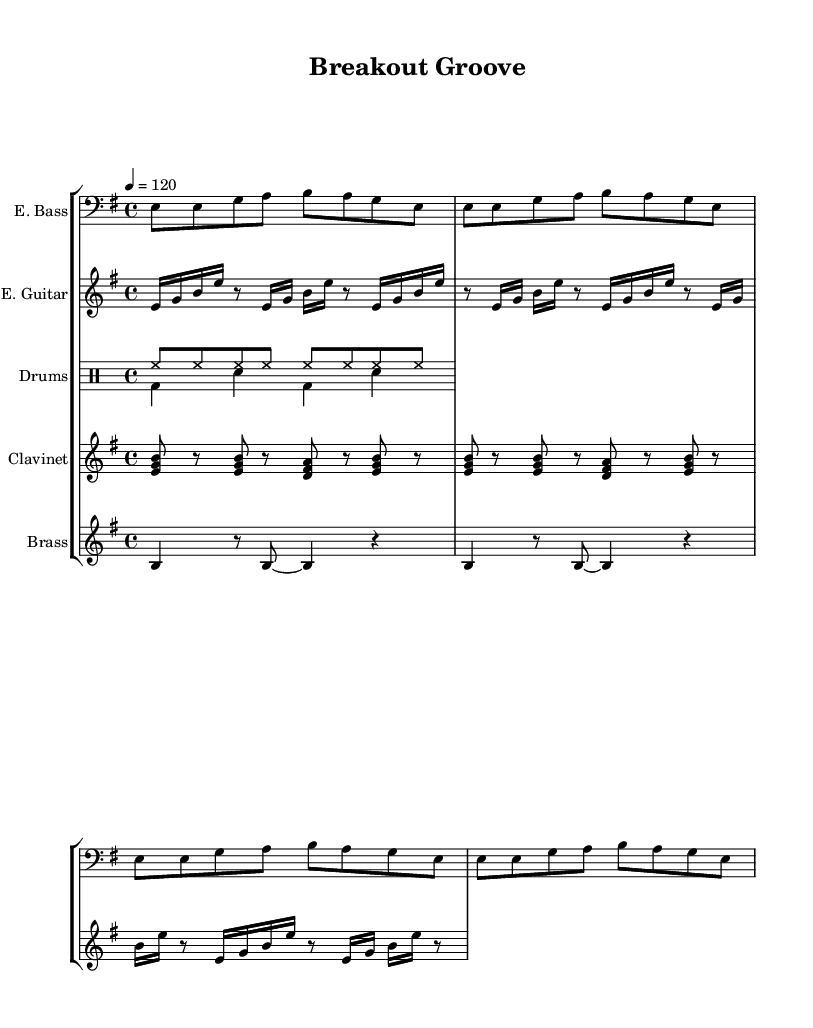What is the key signature of this music? The key signature of the piece is E minor, which has one sharp (F#). This is found at the beginning of the score.
Answer: E minor What is the time signature of this music? The time signature shown in the score is 4/4, which means there are four beats in a measure and the quarter note gets one beat. This is indicated at the start of the music.
Answer: 4/4 What is the tempo marking of this music? The tempo marking indicates a tempo of 120 beats per minute, shown as "4 = 120" in the score. This means the quarter note is played at a tempo of 120.
Answer: 120 How many measures does the electric bass part repeat? The electric bass part has a repeating pattern that unfolds 4 times, as indicated by "repeat unfold 4" in the score. This means the same sequence of notes is played for four measures.
Answer: 4 What instruments are present in this piece? The instruments listed in the score are electric bass, electric guitar, drums, clavinet, and brass section. This information is found in the "Staff" descriptions.
Answer: Electric bass, electric guitar, drums, clavinet, brass Which instrument plays the rhythm section's hi-hat pattern? The hi-hat pattern is played by the drums, specifically in the drum voice that is labeled as "hihat8" in the score, suggesting it is part of the drum kit setup.
Answer: Drums What type of chord is primarily used in the clavinet section? The clavinet section plays major chords, such as E major and D major based on the notes played, which typically emphasize the upbeat feel of funk music.
Answer: Major chords 